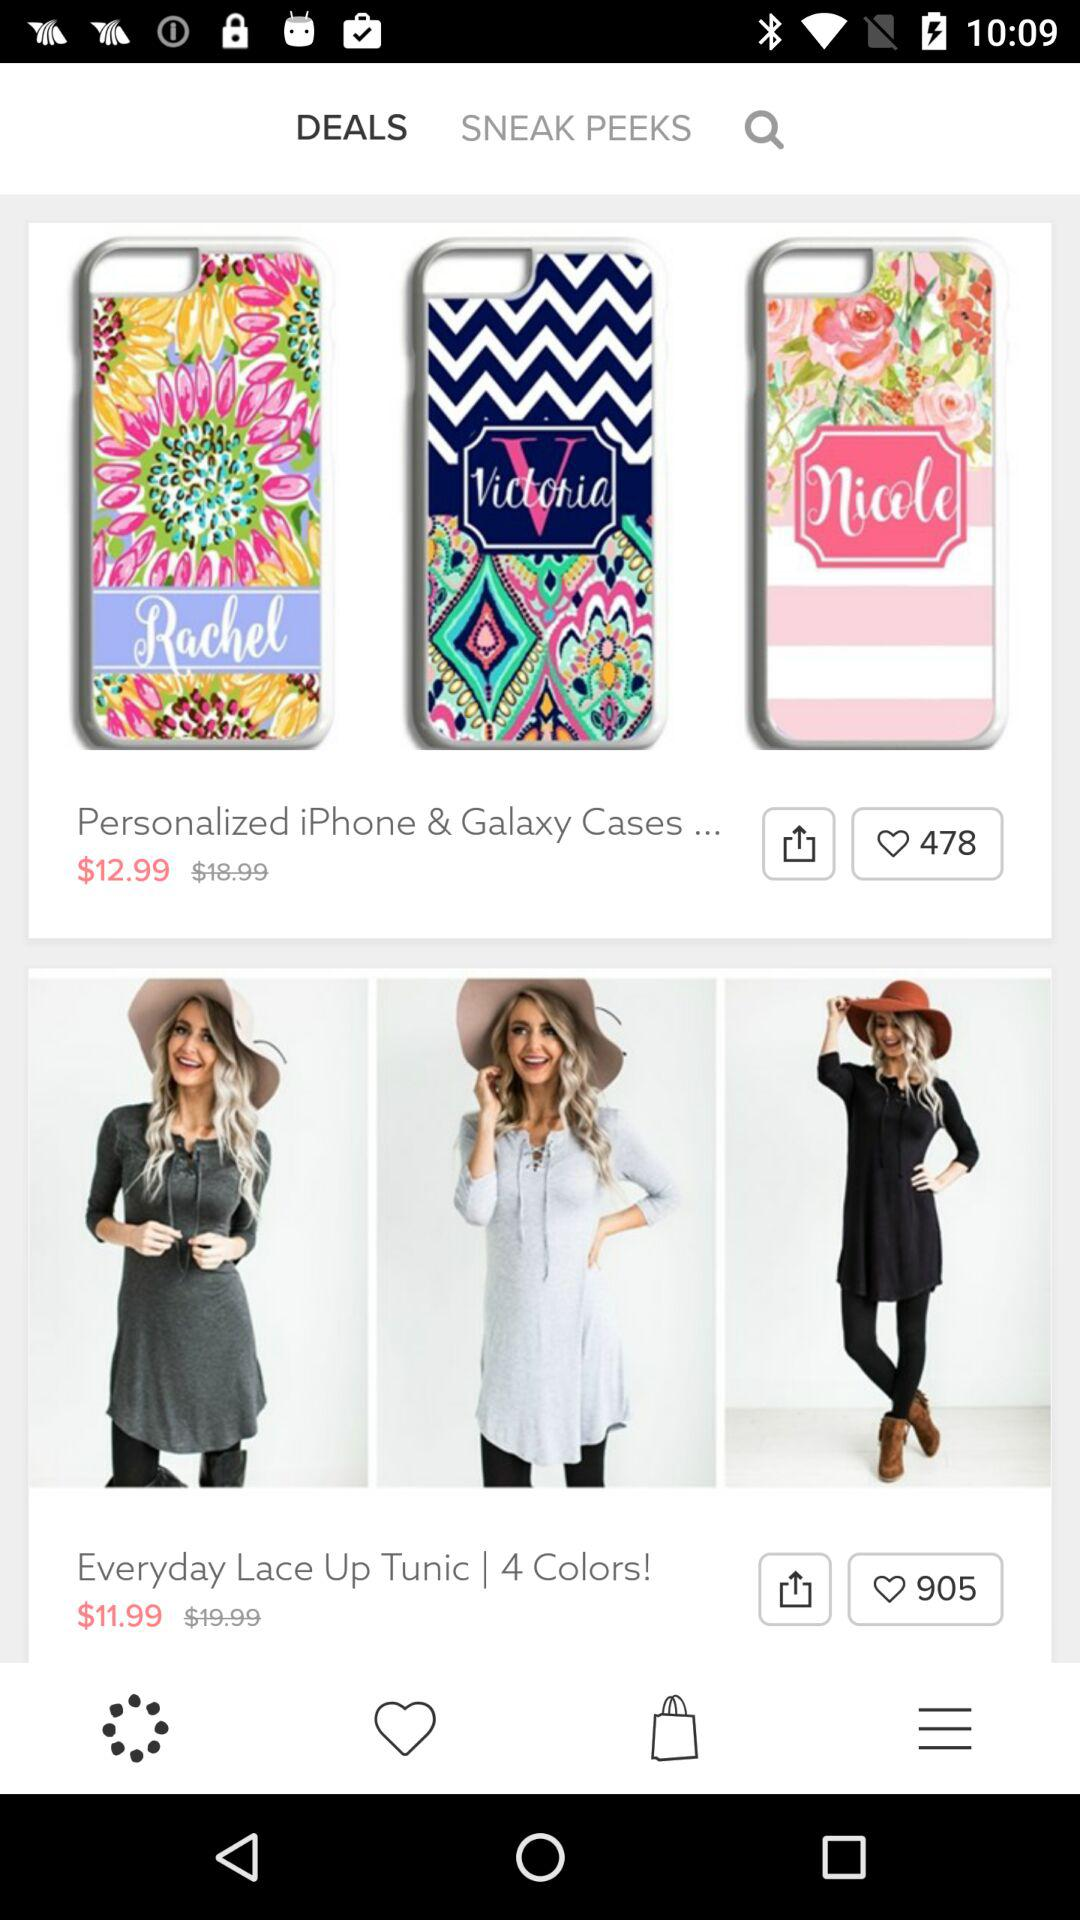How many items are in the top section of the screen?
Answer the question using a single word or phrase. 3 